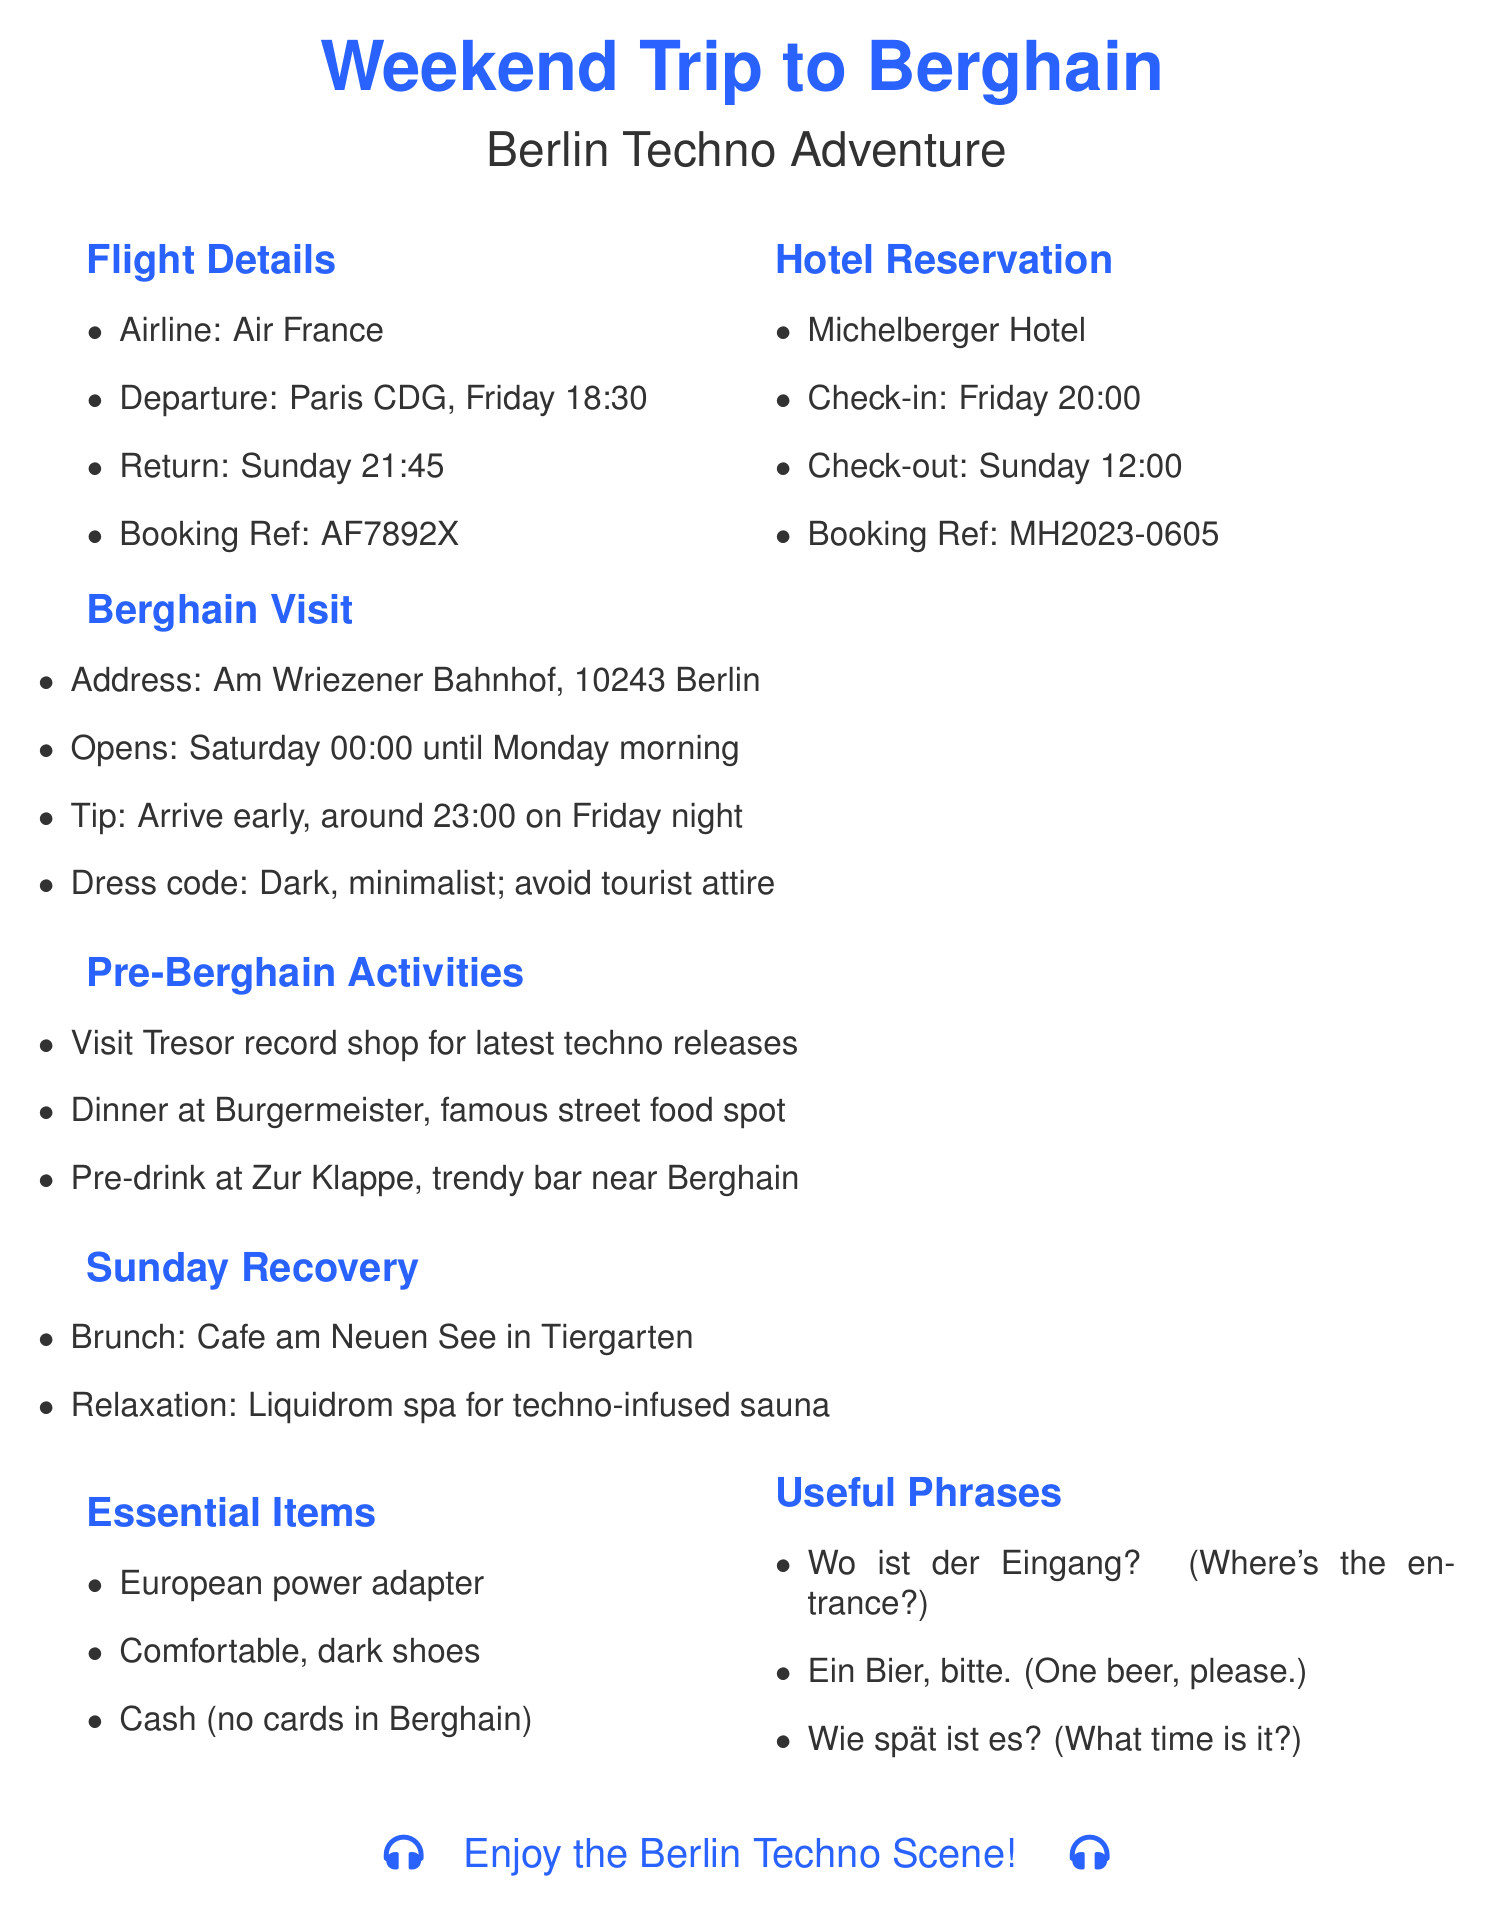What airline is used for the flight? The airline is listed under flight details, which is Air France.
Answer: Air France What is the check-in time for the hotel? The check-in time is specified in the hotel reservation section as Friday at 20:00.
Answer: 20:00 What is the booking reference for the flight? The booking reference for the flight can be found in the flight details section.
Answer: AF7892X What are the opening hours for Berghain? The opening hours are provided in the Berghain visit section, stating it opens Saturday at 00:00 until Monday morning.
Answer: Saturday 00:00 - Monday morning Which bar is recommended for pre-drinks? The pre-Berghain activities mention a specific trendy bar for pre-drinks, named Zur Klappe.
Answer: Zur Klappe What is the address of the Michelberger Hotel? The address of the hotel is provided in the hotel reservation section.
Answer: Warschauer Str. 39-40, 10243 Berlin What is the dress code for Berghain? The dress code is mentioned in the Berghain visit section, which emphasizes the style of clothing to wear.
Answer: Dark, minimalist clothing; avoid obvious tourist attire What activity is suggested for Sunday recovery? The Sunday recovery section lists the activities planned for recovery, mentioning a specific spa.
Answer: Liquidrom spa for techno-infused sauna experience How many activities are listed before going to Berghain? The pre-Berghain activities section lists three specific activities to do prior to visiting the club.
Answer: 3 